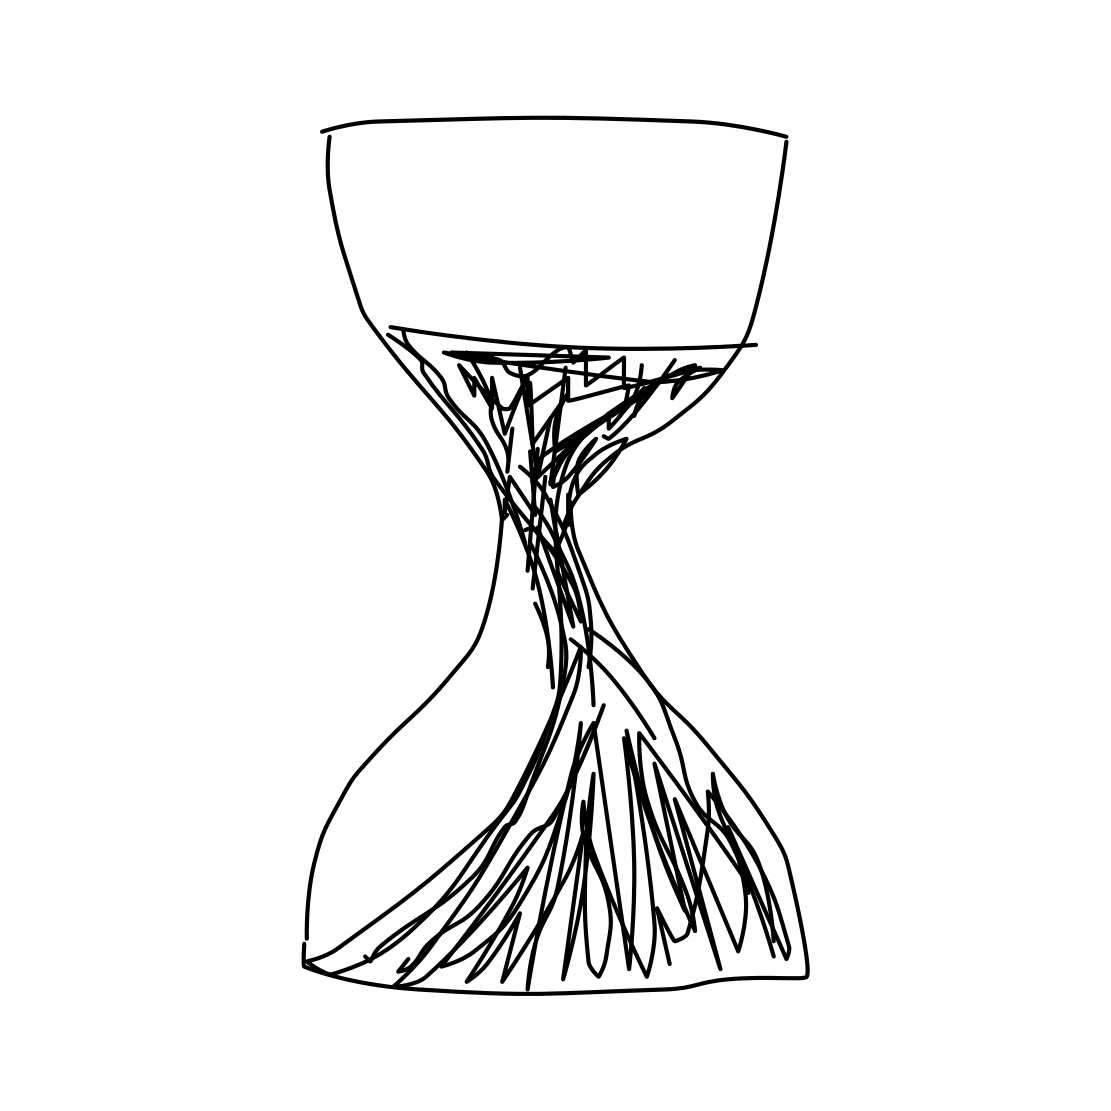Can you tell me about the style of this drawing? Certainly! The drawing has a sketch-like appearance, characterized by its use of unrefined lines that give it a raw, energetic quality. The depiction leans towards an abstract or expressionist style, where the focus is more on conveying a concept or emotion rather than replicating a realistic image. 